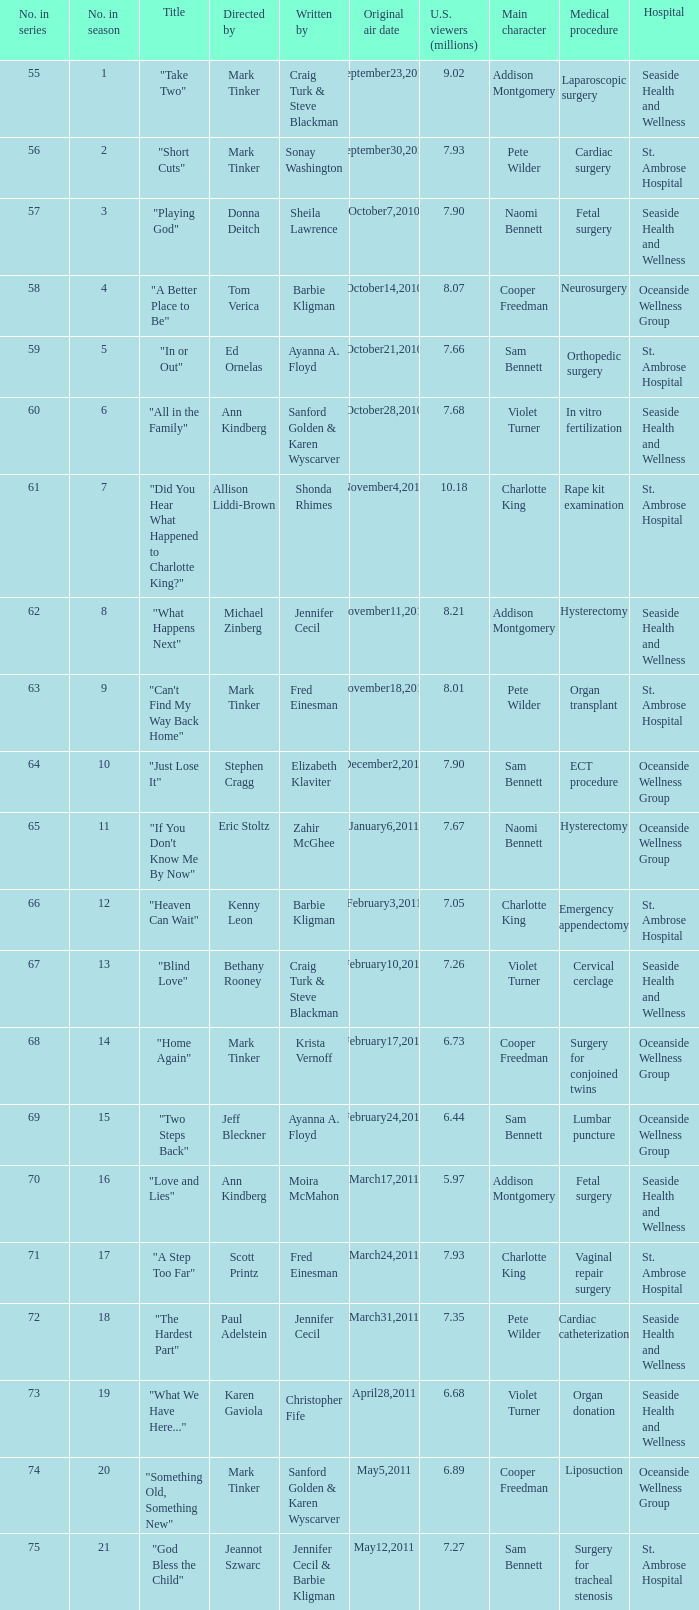What number episode in the season was directed by Paul Adelstein?  18.0. 